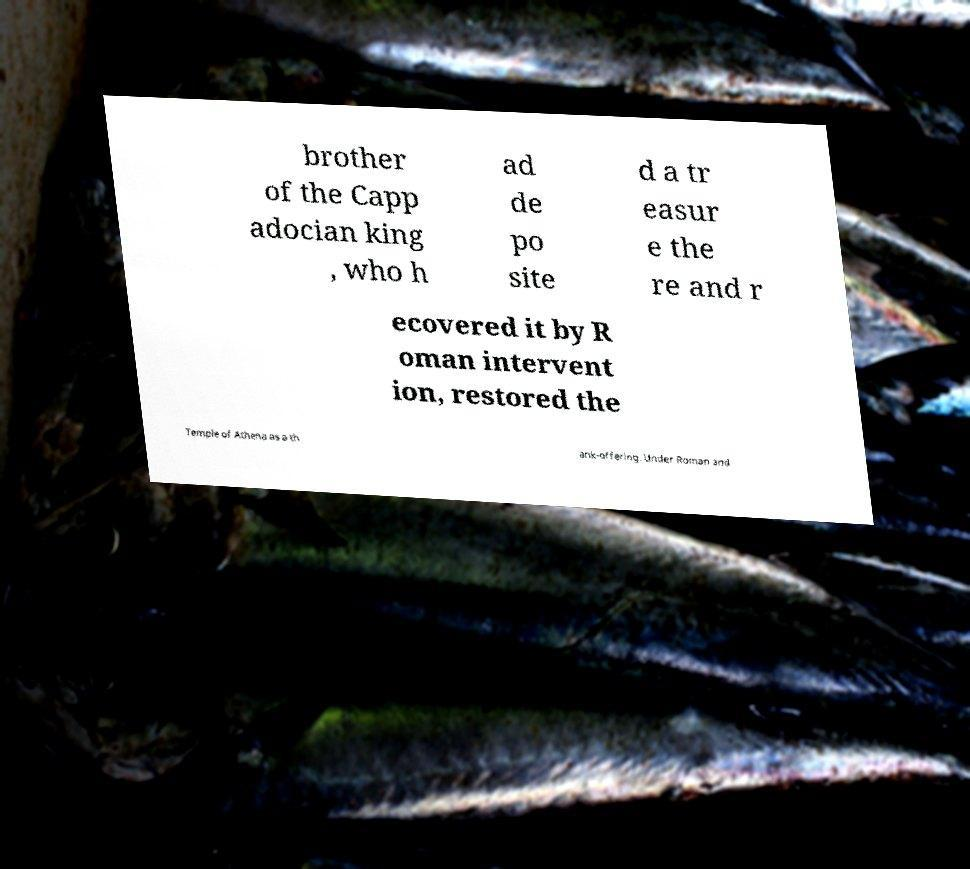I need the written content from this picture converted into text. Can you do that? brother of the Capp adocian king , who h ad de po site d a tr easur e the re and r ecovered it by R oman intervent ion, restored the Temple of Athena as a th ank-offering. Under Roman and 